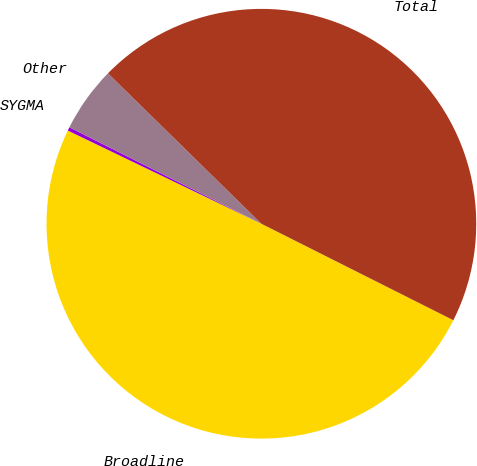Convert chart to OTSL. <chart><loc_0><loc_0><loc_500><loc_500><pie_chart><fcel>Broadline<fcel>SYGMA<fcel>Other<fcel>Total<nl><fcel>49.73%<fcel>0.27%<fcel>4.93%<fcel>45.07%<nl></chart> 